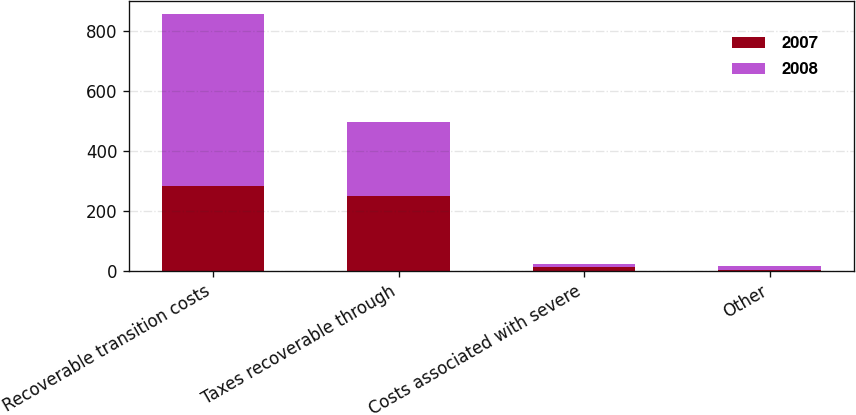Convert chart. <chart><loc_0><loc_0><loc_500><loc_500><stacked_bar_chart><ecel><fcel>Recoverable transition costs<fcel>Taxes recoverable through<fcel>Costs associated with severe<fcel>Other<nl><fcel>2007<fcel>281<fcel>250<fcel>11<fcel>3<nl><fcel>2008<fcel>574<fcel>245<fcel>12<fcel>12<nl></chart> 